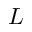<formula> <loc_0><loc_0><loc_500><loc_500>L</formula> 